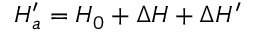<formula> <loc_0><loc_0><loc_500><loc_500>H _ { a } ^ { \prime } = H _ { 0 } + \Delta H + \Delta H ^ { \prime }</formula> 